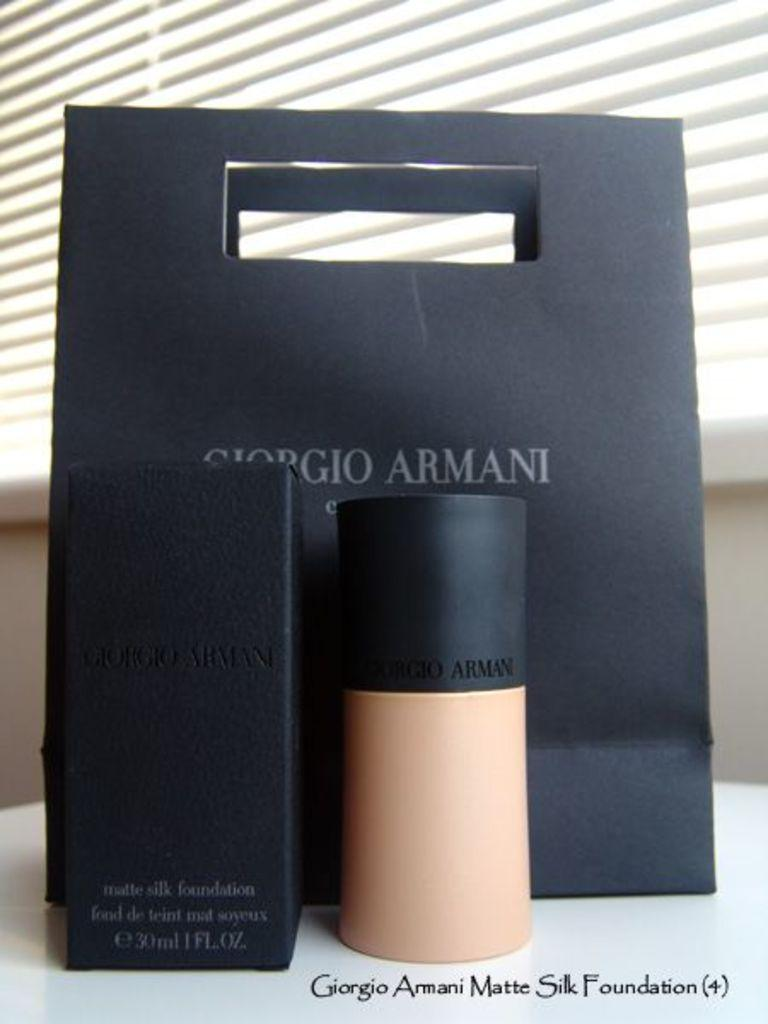<image>
Present a compact description of the photo's key features. a display of Giorgio Armani foundation with the box and bag 